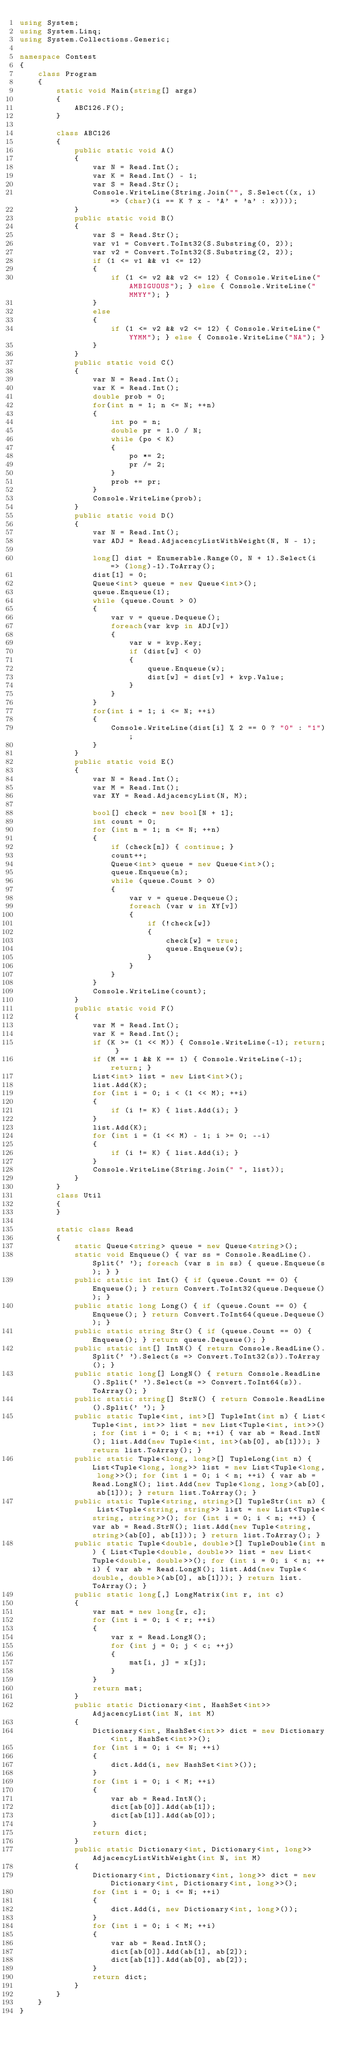<code> <loc_0><loc_0><loc_500><loc_500><_C#_>using System;
using System.Linq;
using System.Collections.Generic;

namespace Contest
{
    class Program
    {
        static void Main(string[] args)
        {
            ABC126.F();
        }

        class ABC126
        {
            public static void A()
            {
                var N = Read.Int();
                var K = Read.Int() - 1;
                var S = Read.Str();
                Console.WriteLine(String.Join("", S.Select((x, i) => (char)(i == K ? x - 'A' + 'a' : x))));
            }
            public static void B()
            {
                var S = Read.Str();
                var v1 = Convert.ToInt32(S.Substring(0, 2));
                var v2 = Convert.ToInt32(S.Substring(2, 2));
                if (1 <= v1 && v1 <= 12)
                {
                    if (1 <= v2 && v2 <= 12) { Console.WriteLine("AMBIGUOUS"); } else { Console.WriteLine("MMYY"); }
                }
                else
                {
                    if (1 <= v2 && v2 <= 12) { Console.WriteLine("YYMM"); } else { Console.WriteLine("NA"); }
                }
            }
            public static void C()
            {
                var N = Read.Int();
                var K = Read.Int();
                double prob = 0;
                for(int n = 1; n <= N; ++n)
                {
                    int po = n;
                    double pr = 1.0 / N;
                    while (po < K)
                    {
                        po *= 2;
                        pr /= 2;
                    }
                    prob += pr;
                }
                Console.WriteLine(prob);
            }
            public static void D()
            {
                var N = Read.Int();
                var ADJ = Read.AdjacencyListWithWeight(N, N - 1);

                long[] dist = Enumerable.Range(0, N + 1).Select(i => (long)-1).ToArray();
                dist[1] = 0;
                Queue<int> queue = new Queue<int>();
                queue.Enqueue(1);
                while (queue.Count > 0)
                {
                    var v = queue.Dequeue();
                    foreach(var kvp in ADJ[v])
                    {
                        var w = kvp.Key;
                        if (dist[w] < 0)
                        {
                            queue.Enqueue(w);
                            dist[w] = dist[v] + kvp.Value;
                        }
                    }
                }
                for(int i = 1; i <= N; ++i)
                {
                    Console.WriteLine(dist[i] % 2 == 0 ? "0" : "1");
                }
            }
            public static void E()
            {
                var N = Read.Int();
                var M = Read.Int();
                var XY = Read.AdjacencyList(N, M);

                bool[] check = new bool[N + 1];
                int count = 0;
                for (int n = 1; n <= N; ++n)
                {
                    if (check[n]) { continue; }
                    count++;
                    Queue<int> queue = new Queue<int>();
                    queue.Enqueue(n);
                    while (queue.Count > 0)
                    {
                        var v = queue.Dequeue();
                        foreach (var w in XY[v])
                        {
                            if (!check[w])
                            {
                                check[w] = true;
                                queue.Enqueue(w);
                            }
                        }
                    }
                }
                Console.WriteLine(count);
            }
            public static void F()
            {
                var M = Read.Int();
                var K = Read.Int();
                if (K >= (1 << M)) { Console.WriteLine(-1); return; }
                if (M == 1 && K == 1) { Console.WriteLine(-1); return; }
                List<int> list = new List<int>();
                list.Add(K);
                for (int i = 0; i < (1 << M); ++i)
                {
                    if (i != K) { list.Add(i); }
                }
                list.Add(K);
                for (int i = (1 << M) - 1; i >= 0; --i)
                {
                    if (i != K) { list.Add(i); }
                }
                Console.WriteLine(String.Join(" ", list));
            }
        }
        class Util
        {
        }

        static class Read
        {
            static Queue<string> queue = new Queue<string>();
            static void Enqueue() { var ss = Console.ReadLine().Split(' '); foreach (var s in ss) { queue.Enqueue(s); } }
            public static int Int() { if (queue.Count == 0) { Enqueue(); } return Convert.ToInt32(queue.Dequeue()); }
            public static long Long() { if (queue.Count == 0) { Enqueue(); } return Convert.ToInt64(queue.Dequeue()); }
            public static string Str() { if (queue.Count == 0) { Enqueue(); } return queue.Dequeue(); }
            public static int[] IntN() { return Console.ReadLine().Split(' ').Select(s => Convert.ToInt32(s)).ToArray(); }
            public static long[] LongN() { return Console.ReadLine().Split(' ').Select(s => Convert.ToInt64(s)).ToArray(); }
            public static string[] StrN() { return Console.ReadLine().Split(' '); }
            public static Tuple<int, int>[] TupleInt(int n) { List<Tuple<int, int>> list = new List<Tuple<int, int>>(); for (int i = 0; i < n; ++i) { var ab = Read.IntN(); list.Add(new Tuple<int, int>(ab[0], ab[1])); } return list.ToArray(); }
            public static Tuple<long, long>[] TupleLong(int n) { List<Tuple<long, long>> list = new List<Tuple<long, long>>(); for (int i = 0; i < n; ++i) { var ab = Read.LongN(); list.Add(new Tuple<long, long>(ab[0], ab[1])); } return list.ToArray(); }
            public static Tuple<string, string>[] TupleStr(int n) { List<Tuple<string, string>> list = new List<Tuple<string, string>>(); for (int i = 0; i < n; ++i) { var ab = Read.StrN(); list.Add(new Tuple<string, string>(ab[0], ab[1])); } return list.ToArray(); }
            public static Tuple<double, double>[] TupleDouble(int n) { List<Tuple<double, double>> list = new List<Tuple<double, double>>(); for (int i = 0; i < n; ++i) { var ab = Read.LongN(); list.Add(new Tuple<double, double>(ab[0], ab[1])); } return list.ToArray(); }
            public static long[,] LongMatrix(int r, int c)
            {
                var mat = new long[r, c];
                for (int i = 0; i < r; ++i)
                {
                    var x = Read.LongN();
                    for (int j = 0; j < c; ++j)
                    {
                        mat[i, j] = x[j];
                    }
                }
                return mat;
            }
            public static Dictionary<int, HashSet<int>> AdjacencyList(int N, int M)
            {
                Dictionary<int, HashSet<int>> dict = new Dictionary<int, HashSet<int>>();
                for (int i = 0; i <= N; ++i)
                {
                    dict.Add(i, new HashSet<int>());
                }
                for (int i = 0; i < M; ++i)
                {
                    var ab = Read.IntN();
                    dict[ab[0]].Add(ab[1]);
                    dict[ab[1]].Add(ab[0]);
                }
                return dict;
            }
            public static Dictionary<int, Dictionary<int, long>> AdjacencyListWithWeight(int N, int M)
            {
                Dictionary<int, Dictionary<int, long>> dict = new Dictionary<int, Dictionary<int, long>>();
                for (int i = 0; i <= N; ++i)
                {
                    dict.Add(i, new Dictionary<int, long>());
                }
                for (int i = 0; i < M; ++i)
                {
                    var ab = Read.IntN();
                    dict[ab[0]].Add(ab[1], ab[2]);
                    dict[ab[1]].Add(ab[0], ab[2]);
                }
                return dict;
            }
        }
    }
}
</code> 